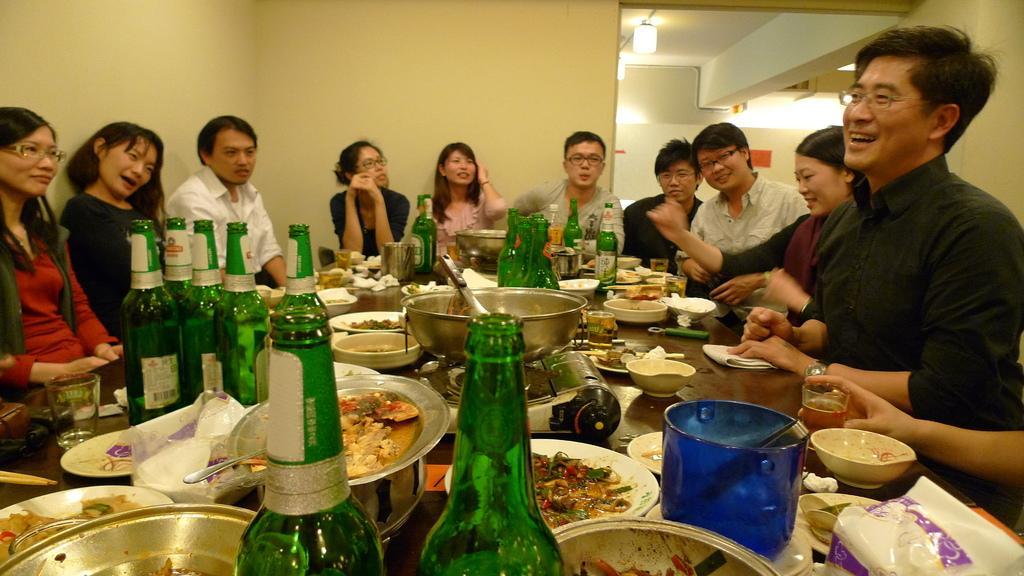How would you summarize this image in a sentence or two? There are group of persons sitting around the table which has some eatables and drink bottles on it. 